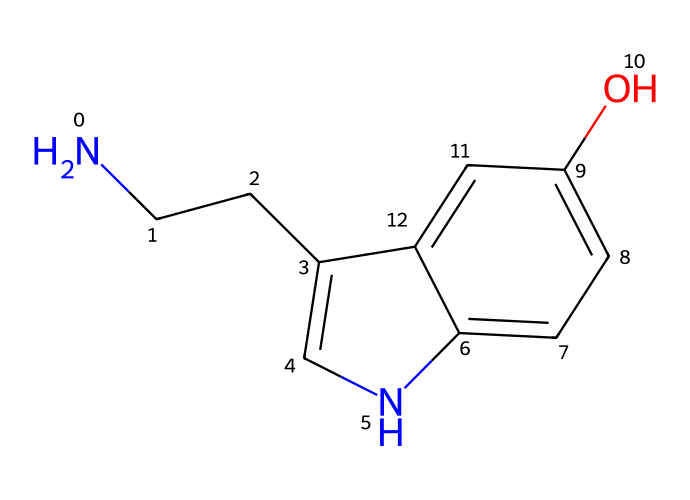What is the molecular formula of serotonin? To determine the molecular formula, we analyze the SMILES structure. The components include carbon (C), hydrogen (H), nitrogen (N), and oxygen (O). Counting the atoms gives us C10, H12, N2, and O1. Therefore, the molecular formula is C10H12N2O.
Answer: C10H12N2O How many rings are present in the serotonin structure? By examining the SMILES representation, we see there are two cyclic components indicated by the 'c' which represent aromatic carbons. This confirms two fused rings are present in the structure.
Answer: 2 What functional group is present in serotonin? The hydroxyl group (–OH) indicated by the 'O' connected to the cyclic structure represents a phenolic –OH group. This is a major functional group that influences its reactivity and bioactivity as a neurotransmitter.
Answer: hydroxyl What is the role of nitrogen in serotonin? The presence of nitrogen in serotonin contributes to its classification as an amine, which is crucial for its function as a neurotransmitter that interacts with receptors in the nervous system.
Answer: neurotransmitter How does the structure of serotonin relate to its biological function? The structure allows serotonin to fit into the receptor sites in the brain due to its specific shape and ability to form hydrogen bonds through its hydroxyl and amine groups, facilitating communication between neurons.
Answer: receptor interaction What type of bonding is found between the atoms in serotonin? The SMILES representation shows various types of bonding, including covalent bonds between carbon and nitrogen, and also between carbon and oxygen in the hydroxyl group, which are essential for the stability and function of the molecule.
Answer: covalent bonding 